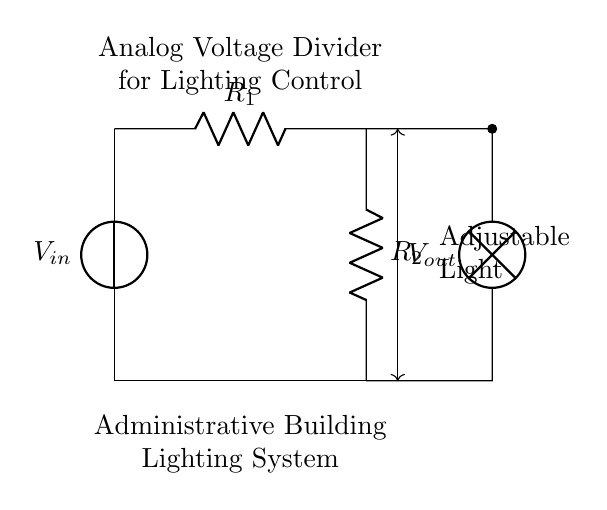What components are present in the circuit? The circuit contains a voltage source, two resistors, and a lamp. These components are essential for functioning as a voltage divider and adjusting the light intensity.
Answer: voltage source, two resistors, lamp What is the function of the adjustable light in this circuit? The adjustable light's function is to vary its intensity based on the output voltage from the voltage divider formed by the resistors. This allows control over the brightness of the lamp used for lighting.
Answer: vary intensity What are the resistor values used in this circuit? The circuit diagram does not specify exact numerical values for the resistors; however, they are labeled generically as R1 and R2. Their values would determine the output voltage.
Answer: R1, R2 What type of circuit is this? This is an analog voltage divider circuit. It allows for analog control over the output voltage that affects the brightness of the lighting.
Answer: analog voltage divider How does the output voltage vary with changes in the resistor values? The output voltage decreases as the resistance of the resistors increases (and vice versa) based on the voltage divider principle, which states that the output voltage is proportional to the ratio of the resistors.
Answer: voltage divider principle What is the relationship between input voltage and output voltage in this circuit? The relationship is given by the voltage divider formula. The output voltage is equal to the input voltage multiplied by the fraction of the second resistor divided by the total resistance of both resistors.
Answer: voltage divider formula 